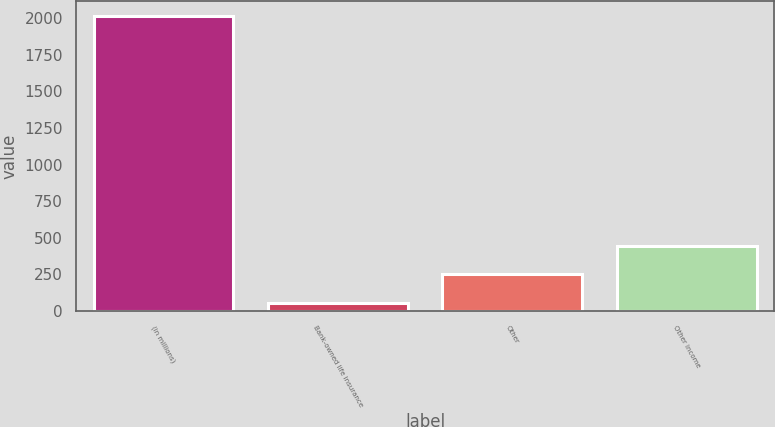Convert chart. <chart><loc_0><loc_0><loc_500><loc_500><bar_chart><fcel>(in millions)<fcel>Bank-owned life insurance<fcel>Other<fcel>Other income<nl><fcel>2016<fcel>54<fcel>250.2<fcel>446.4<nl></chart> 